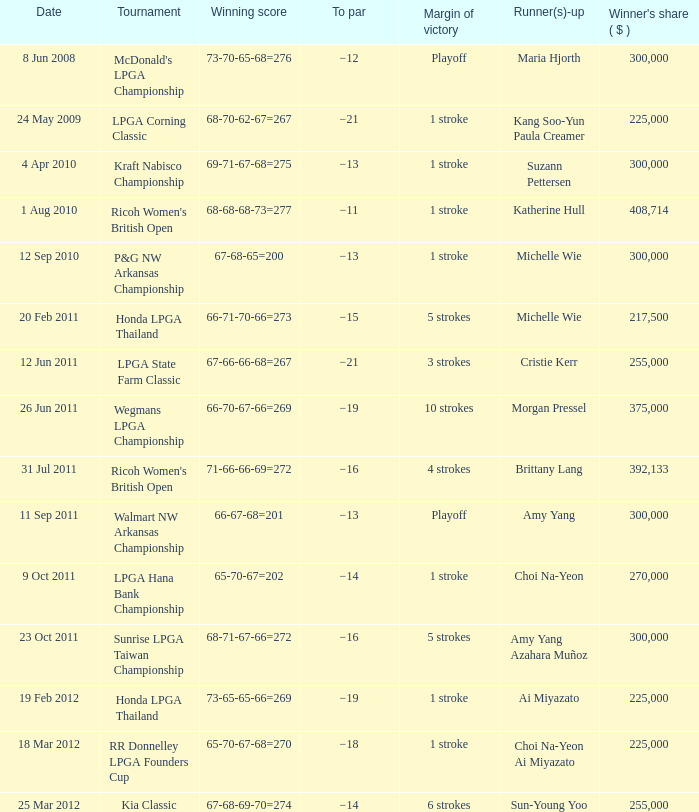Who was the runner-up in the RR Donnelley LPGA Founders Cup? Choi Na-Yeon Ai Miyazato. 